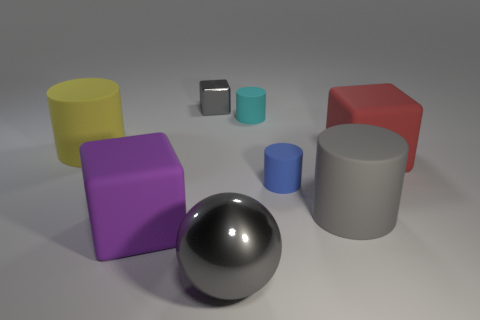Subtract all brown blocks. Subtract all green cylinders. How many blocks are left? 3 Add 2 gray blocks. How many objects exist? 10 Subtract all spheres. How many objects are left? 7 Subtract all tiny gray matte balls. Subtract all large yellow matte cylinders. How many objects are left? 7 Add 3 big gray rubber objects. How many big gray rubber objects are left? 4 Add 3 large yellow rubber cylinders. How many large yellow rubber cylinders exist? 4 Subtract 1 blue cylinders. How many objects are left? 7 